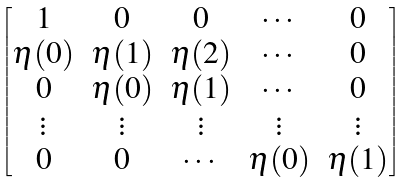Convert formula to latex. <formula><loc_0><loc_0><loc_500><loc_500>\begin{bmatrix} 1 & 0 & 0 & \cdots & 0 \\ \eta ( 0 ) & \eta ( 1 ) & \eta ( 2 ) & \cdots & 0 \\ 0 & \eta ( 0 ) & \eta ( 1 ) & \cdots & 0 \\ \vdots & \vdots & \vdots & \vdots & \vdots \\ 0 & 0 & \cdots & \eta ( 0 ) & \eta ( 1 ) \end{bmatrix}</formula> 